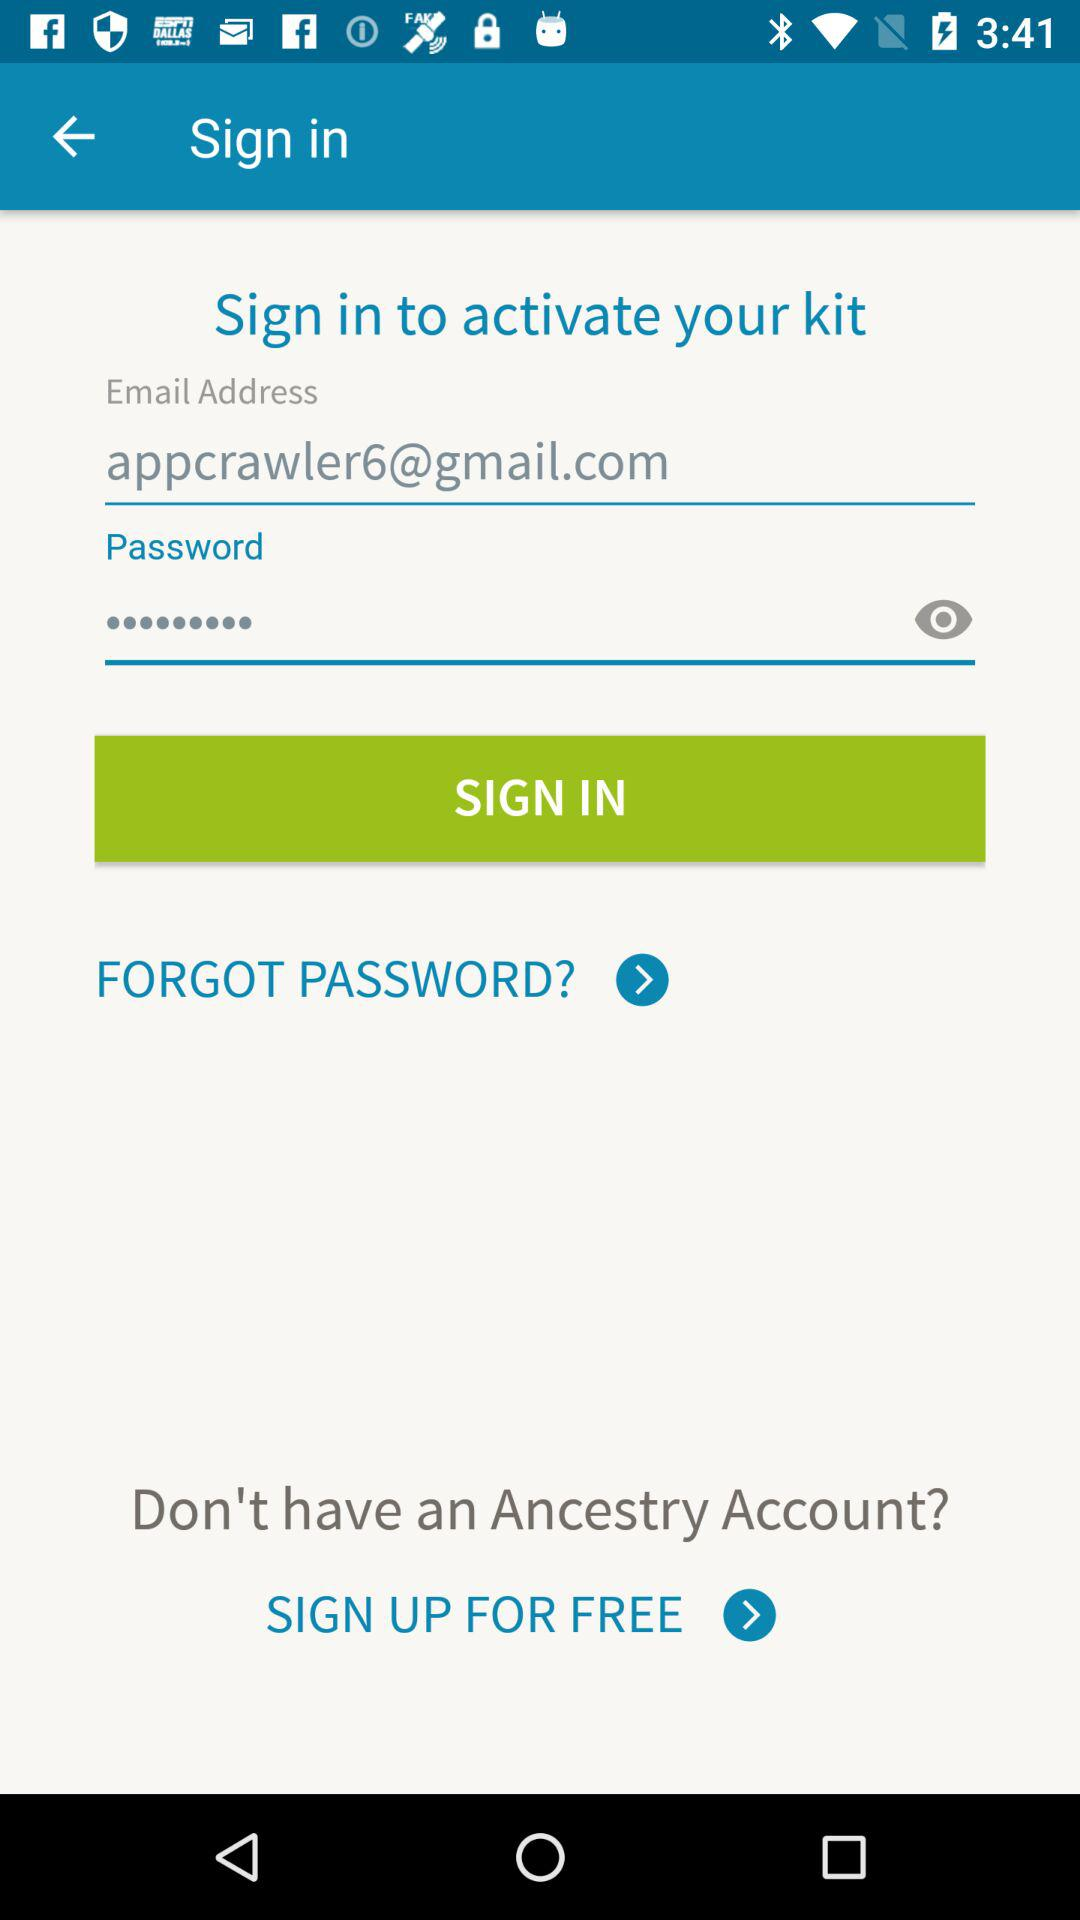Can we reset password?
When the provided information is insufficient, respond with <no answer>. <no answer> 